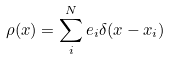Convert formula to latex. <formula><loc_0><loc_0><loc_500><loc_500>\rho ( x ) = \sum _ { i } ^ { N } e _ { i } \delta ( x - x _ { i } )</formula> 